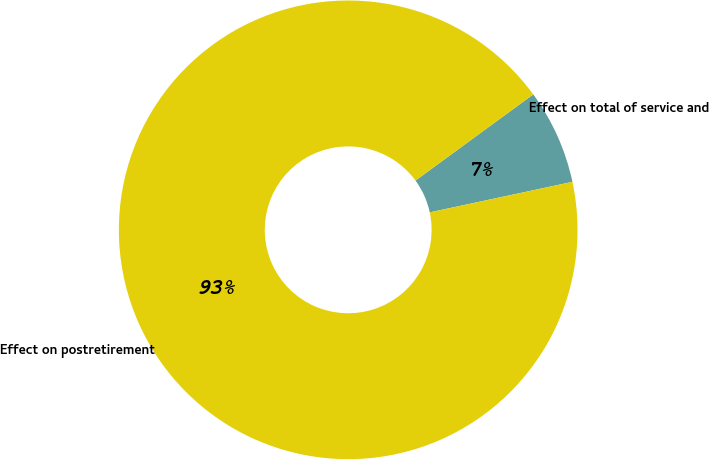Convert chart. <chart><loc_0><loc_0><loc_500><loc_500><pie_chart><fcel>Effect on total of service and<fcel>Effect on postretirement<nl><fcel>6.7%<fcel>93.3%<nl></chart> 